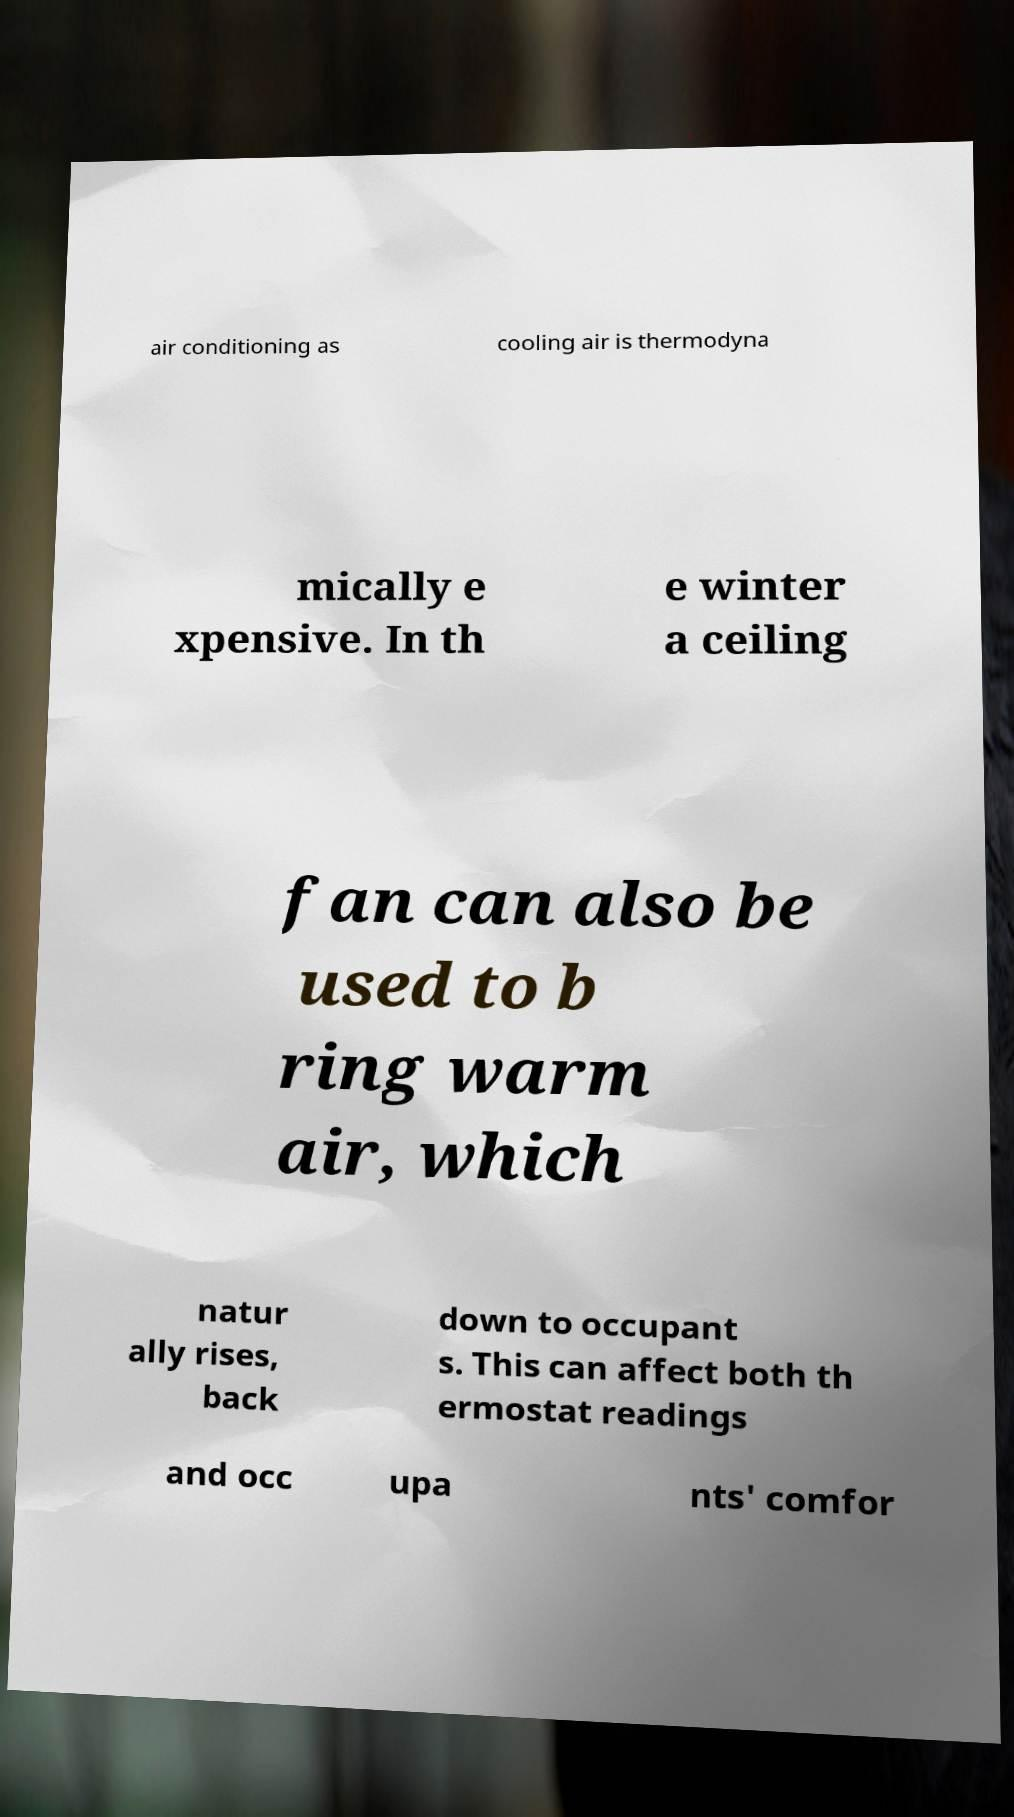What messages or text are displayed in this image? I need them in a readable, typed format. air conditioning as cooling air is thermodyna mically e xpensive. In th e winter a ceiling fan can also be used to b ring warm air, which natur ally rises, back down to occupant s. This can affect both th ermostat readings and occ upa nts' comfor 